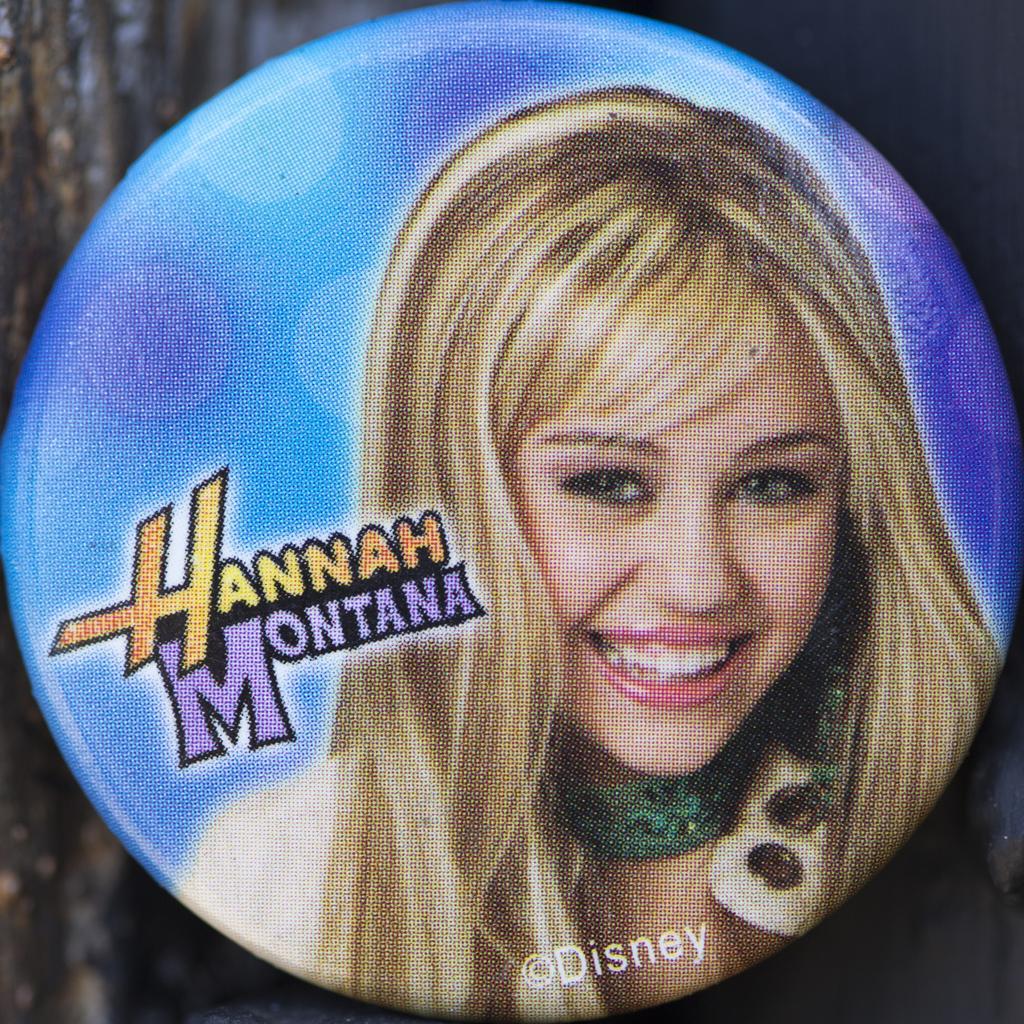Can you describe this image briefly? In this image there is a badge with Hannah Montana photography. 